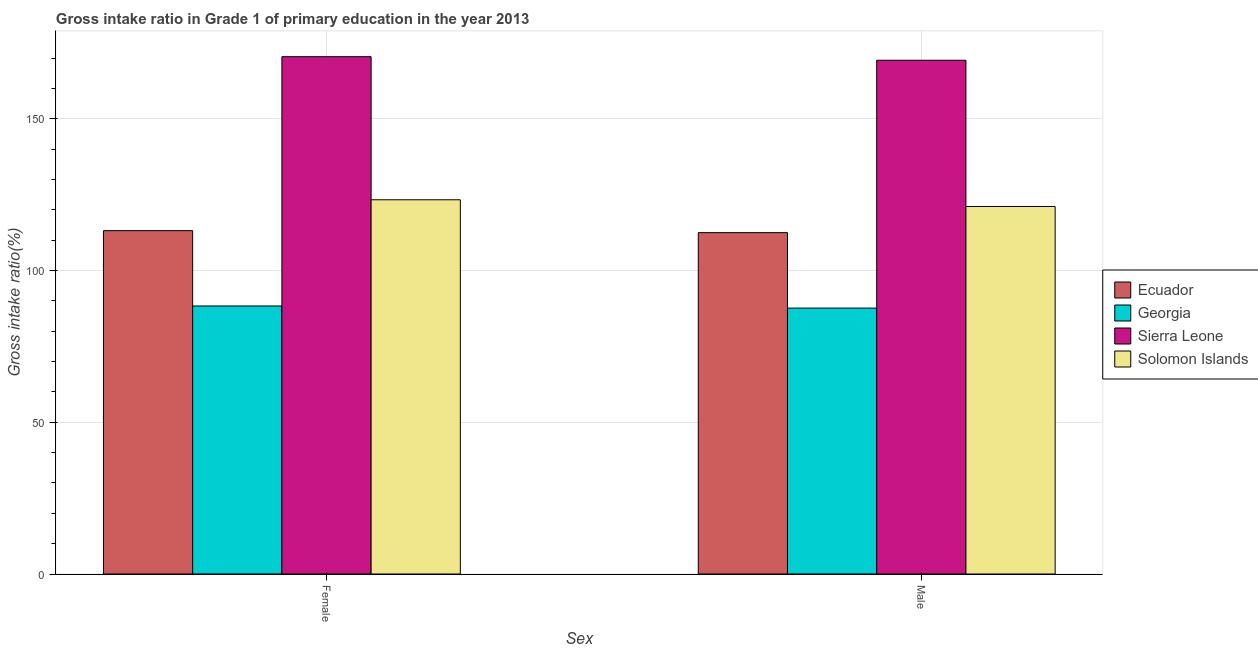How many bars are there on the 2nd tick from the left?
Your answer should be compact. 4. What is the gross intake ratio(male) in Sierra Leone?
Provide a succinct answer. 169.27. Across all countries, what is the maximum gross intake ratio(female)?
Make the answer very short. 170.45. Across all countries, what is the minimum gross intake ratio(male)?
Offer a terse response. 87.62. In which country was the gross intake ratio(male) maximum?
Ensure brevity in your answer.  Sierra Leone. In which country was the gross intake ratio(female) minimum?
Ensure brevity in your answer.  Georgia. What is the total gross intake ratio(male) in the graph?
Provide a short and direct response. 490.45. What is the difference between the gross intake ratio(female) in Georgia and that in Ecuador?
Give a very brief answer. -24.82. What is the difference between the gross intake ratio(male) in Solomon Islands and the gross intake ratio(female) in Georgia?
Make the answer very short. 32.78. What is the average gross intake ratio(male) per country?
Your response must be concise. 122.61. What is the difference between the gross intake ratio(female) and gross intake ratio(male) in Solomon Islands?
Offer a very short reply. 2.22. What is the ratio of the gross intake ratio(male) in Ecuador to that in Sierra Leone?
Provide a short and direct response. 0.66. What does the 1st bar from the left in Female represents?
Your answer should be compact. Ecuador. What does the 3rd bar from the right in Female represents?
Provide a succinct answer. Georgia. Are all the bars in the graph horizontal?
Offer a terse response. No. Does the graph contain any zero values?
Ensure brevity in your answer.  No. How many legend labels are there?
Make the answer very short. 4. What is the title of the graph?
Provide a succinct answer. Gross intake ratio in Grade 1 of primary education in the year 2013. What is the label or title of the X-axis?
Provide a succinct answer. Sex. What is the label or title of the Y-axis?
Provide a succinct answer. Gross intake ratio(%). What is the Gross intake ratio(%) of Ecuador in Female?
Ensure brevity in your answer.  113.13. What is the Gross intake ratio(%) in Georgia in Female?
Your response must be concise. 88.31. What is the Gross intake ratio(%) in Sierra Leone in Female?
Offer a terse response. 170.45. What is the Gross intake ratio(%) of Solomon Islands in Female?
Keep it short and to the point. 123.3. What is the Gross intake ratio(%) of Ecuador in Male?
Provide a short and direct response. 112.47. What is the Gross intake ratio(%) in Georgia in Male?
Make the answer very short. 87.62. What is the Gross intake ratio(%) of Sierra Leone in Male?
Make the answer very short. 169.27. What is the Gross intake ratio(%) of Solomon Islands in Male?
Ensure brevity in your answer.  121.09. Across all Sex, what is the maximum Gross intake ratio(%) of Ecuador?
Give a very brief answer. 113.13. Across all Sex, what is the maximum Gross intake ratio(%) in Georgia?
Give a very brief answer. 88.31. Across all Sex, what is the maximum Gross intake ratio(%) of Sierra Leone?
Your answer should be compact. 170.45. Across all Sex, what is the maximum Gross intake ratio(%) in Solomon Islands?
Your response must be concise. 123.3. Across all Sex, what is the minimum Gross intake ratio(%) of Ecuador?
Make the answer very short. 112.47. Across all Sex, what is the minimum Gross intake ratio(%) of Georgia?
Your answer should be compact. 87.62. Across all Sex, what is the minimum Gross intake ratio(%) of Sierra Leone?
Ensure brevity in your answer.  169.27. Across all Sex, what is the minimum Gross intake ratio(%) of Solomon Islands?
Make the answer very short. 121.09. What is the total Gross intake ratio(%) of Ecuador in the graph?
Keep it short and to the point. 225.6. What is the total Gross intake ratio(%) in Georgia in the graph?
Provide a short and direct response. 175.93. What is the total Gross intake ratio(%) of Sierra Leone in the graph?
Ensure brevity in your answer.  339.72. What is the total Gross intake ratio(%) in Solomon Islands in the graph?
Offer a very short reply. 244.39. What is the difference between the Gross intake ratio(%) of Ecuador in Female and that in Male?
Give a very brief answer. 0.66. What is the difference between the Gross intake ratio(%) of Georgia in Female and that in Male?
Make the answer very short. 0.69. What is the difference between the Gross intake ratio(%) in Sierra Leone in Female and that in Male?
Provide a succinct answer. 1.18. What is the difference between the Gross intake ratio(%) of Solomon Islands in Female and that in Male?
Provide a succinct answer. 2.22. What is the difference between the Gross intake ratio(%) of Ecuador in Female and the Gross intake ratio(%) of Georgia in Male?
Provide a succinct answer. 25.51. What is the difference between the Gross intake ratio(%) of Ecuador in Female and the Gross intake ratio(%) of Sierra Leone in Male?
Your answer should be very brief. -56.14. What is the difference between the Gross intake ratio(%) of Ecuador in Female and the Gross intake ratio(%) of Solomon Islands in Male?
Your answer should be very brief. -7.96. What is the difference between the Gross intake ratio(%) in Georgia in Female and the Gross intake ratio(%) in Sierra Leone in Male?
Keep it short and to the point. -80.96. What is the difference between the Gross intake ratio(%) in Georgia in Female and the Gross intake ratio(%) in Solomon Islands in Male?
Offer a very short reply. -32.78. What is the difference between the Gross intake ratio(%) in Sierra Leone in Female and the Gross intake ratio(%) in Solomon Islands in Male?
Your answer should be very brief. 49.36. What is the average Gross intake ratio(%) of Ecuador per Sex?
Your response must be concise. 112.8. What is the average Gross intake ratio(%) of Georgia per Sex?
Your answer should be very brief. 87.97. What is the average Gross intake ratio(%) in Sierra Leone per Sex?
Keep it short and to the point. 169.86. What is the average Gross intake ratio(%) in Solomon Islands per Sex?
Provide a succinct answer. 122.2. What is the difference between the Gross intake ratio(%) in Ecuador and Gross intake ratio(%) in Georgia in Female?
Provide a short and direct response. 24.82. What is the difference between the Gross intake ratio(%) of Ecuador and Gross intake ratio(%) of Sierra Leone in Female?
Offer a very short reply. -57.32. What is the difference between the Gross intake ratio(%) of Ecuador and Gross intake ratio(%) of Solomon Islands in Female?
Offer a terse response. -10.18. What is the difference between the Gross intake ratio(%) in Georgia and Gross intake ratio(%) in Sierra Leone in Female?
Offer a terse response. -82.14. What is the difference between the Gross intake ratio(%) of Georgia and Gross intake ratio(%) of Solomon Islands in Female?
Provide a succinct answer. -34.99. What is the difference between the Gross intake ratio(%) of Sierra Leone and Gross intake ratio(%) of Solomon Islands in Female?
Provide a short and direct response. 47.14. What is the difference between the Gross intake ratio(%) in Ecuador and Gross intake ratio(%) in Georgia in Male?
Offer a terse response. 24.85. What is the difference between the Gross intake ratio(%) of Ecuador and Gross intake ratio(%) of Sierra Leone in Male?
Ensure brevity in your answer.  -56.8. What is the difference between the Gross intake ratio(%) in Ecuador and Gross intake ratio(%) in Solomon Islands in Male?
Offer a very short reply. -8.62. What is the difference between the Gross intake ratio(%) in Georgia and Gross intake ratio(%) in Sierra Leone in Male?
Your answer should be compact. -81.65. What is the difference between the Gross intake ratio(%) in Georgia and Gross intake ratio(%) in Solomon Islands in Male?
Provide a succinct answer. -33.47. What is the difference between the Gross intake ratio(%) of Sierra Leone and Gross intake ratio(%) of Solomon Islands in Male?
Ensure brevity in your answer.  48.18. What is the ratio of the Gross intake ratio(%) in Georgia in Female to that in Male?
Ensure brevity in your answer.  1.01. What is the ratio of the Gross intake ratio(%) in Sierra Leone in Female to that in Male?
Offer a terse response. 1.01. What is the ratio of the Gross intake ratio(%) in Solomon Islands in Female to that in Male?
Ensure brevity in your answer.  1.02. What is the difference between the highest and the second highest Gross intake ratio(%) of Ecuador?
Make the answer very short. 0.66. What is the difference between the highest and the second highest Gross intake ratio(%) of Georgia?
Give a very brief answer. 0.69. What is the difference between the highest and the second highest Gross intake ratio(%) in Sierra Leone?
Provide a succinct answer. 1.18. What is the difference between the highest and the second highest Gross intake ratio(%) of Solomon Islands?
Your answer should be very brief. 2.22. What is the difference between the highest and the lowest Gross intake ratio(%) of Ecuador?
Your answer should be compact. 0.66. What is the difference between the highest and the lowest Gross intake ratio(%) in Georgia?
Your response must be concise. 0.69. What is the difference between the highest and the lowest Gross intake ratio(%) of Sierra Leone?
Provide a short and direct response. 1.18. What is the difference between the highest and the lowest Gross intake ratio(%) of Solomon Islands?
Offer a very short reply. 2.22. 